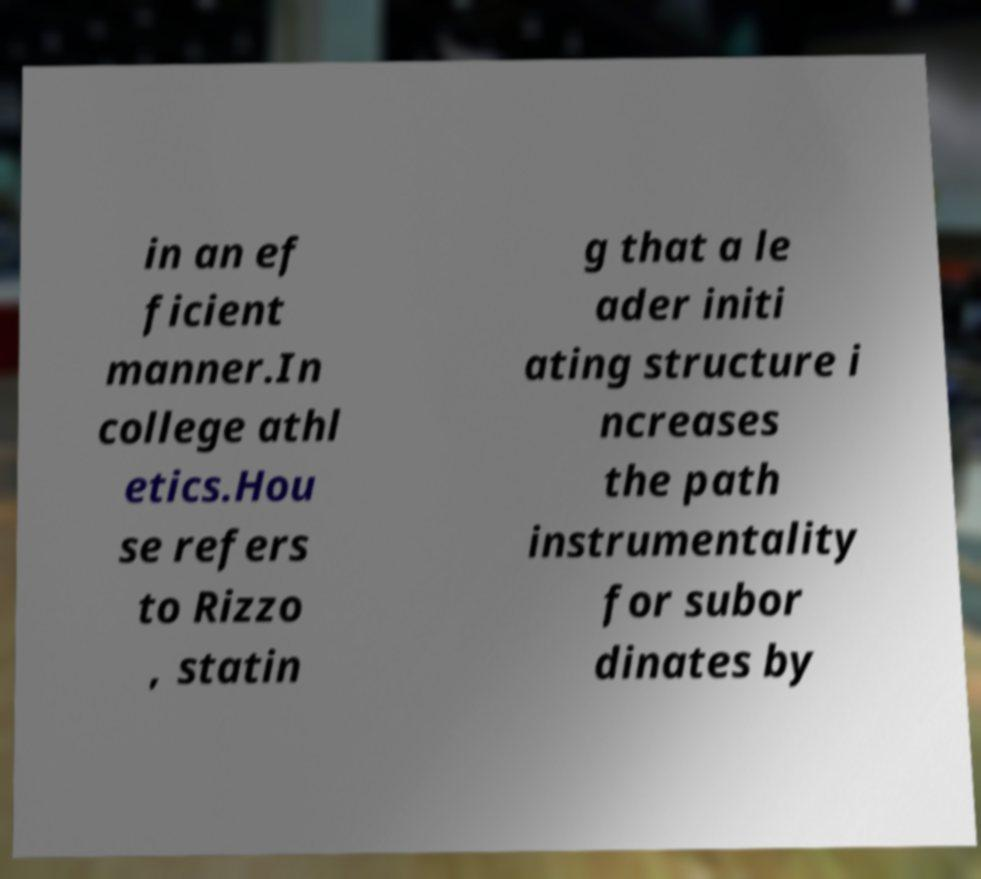I need the written content from this picture converted into text. Can you do that? in an ef ficient manner.In college athl etics.Hou se refers to Rizzo , statin g that a le ader initi ating structure i ncreases the path instrumentality for subor dinates by 